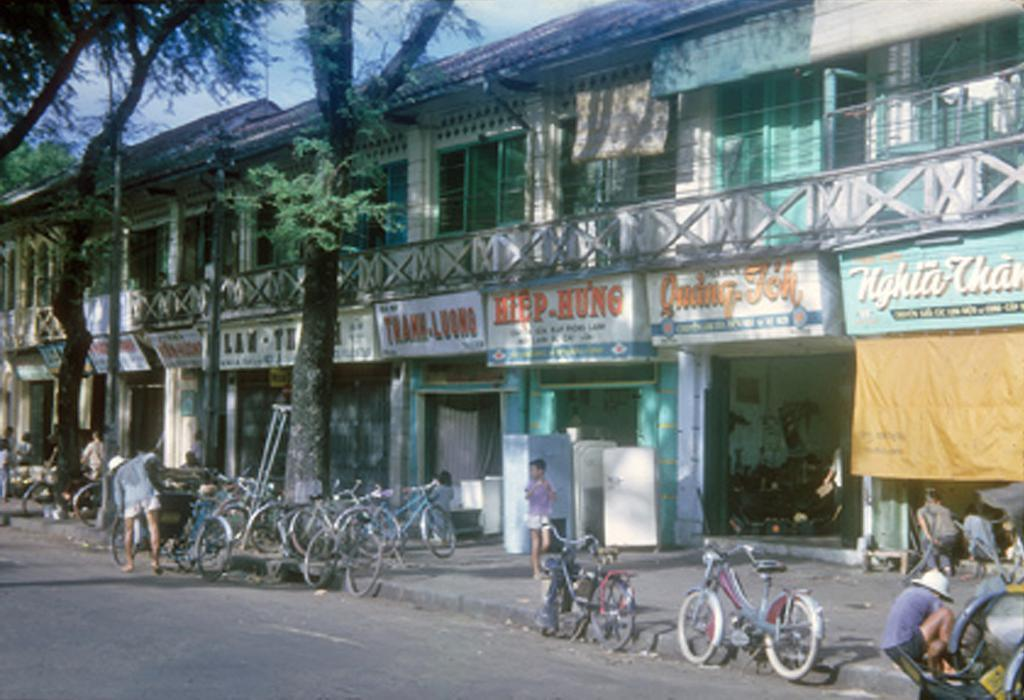What type of establishments can be seen in the image? There are multiple stores in the image. What mode of transportation is parked in front of the stores? There are cycles in front of the stores. What type of vegetation is present in front of the stores? There are trees in front of the stores. Are there any people visible in the image? Yes, there are people in front of the stores. What is the setting of the image? There is a road in front of the stores. What type of horn can be heard coming from the bee in the image? There are no bees present in the image, and therefore no horn can be heard. 